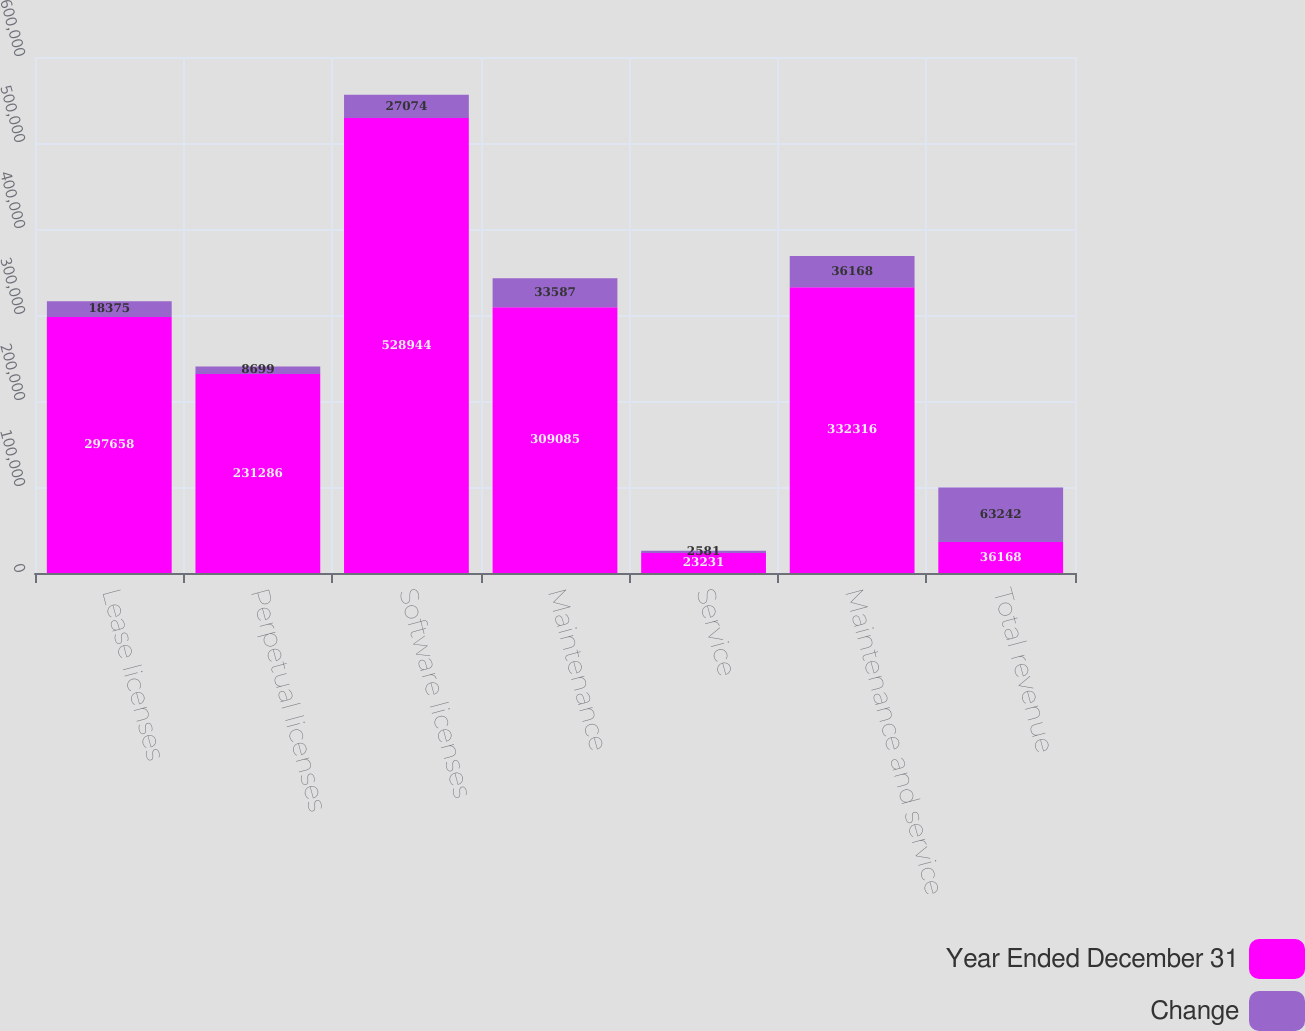<chart> <loc_0><loc_0><loc_500><loc_500><stacked_bar_chart><ecel><fcel>Lease licenses<fcel>Perpetual licenses<fcel>Software licenses<fcel>Maintenance<fcel>Service<fcel>Maintenance and service<fcel>Total revenue<nl><fcel>Year Ended December 31<fcel>297658<fcel>231286<fcel>528944<fcel>309085<fcel>23231<fcel>332316<fcel>36168<nl><fcel>Change<fcel>18375<fcel>8699<fcel>27074<fcel>33587<fcel>2581<fcel>36168<fcel>63242<nl></chart> 